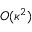<formula> <loc_0><loc_0><loc_500><loc_500>O ( \kappa ^ { 2 } )</formula> 